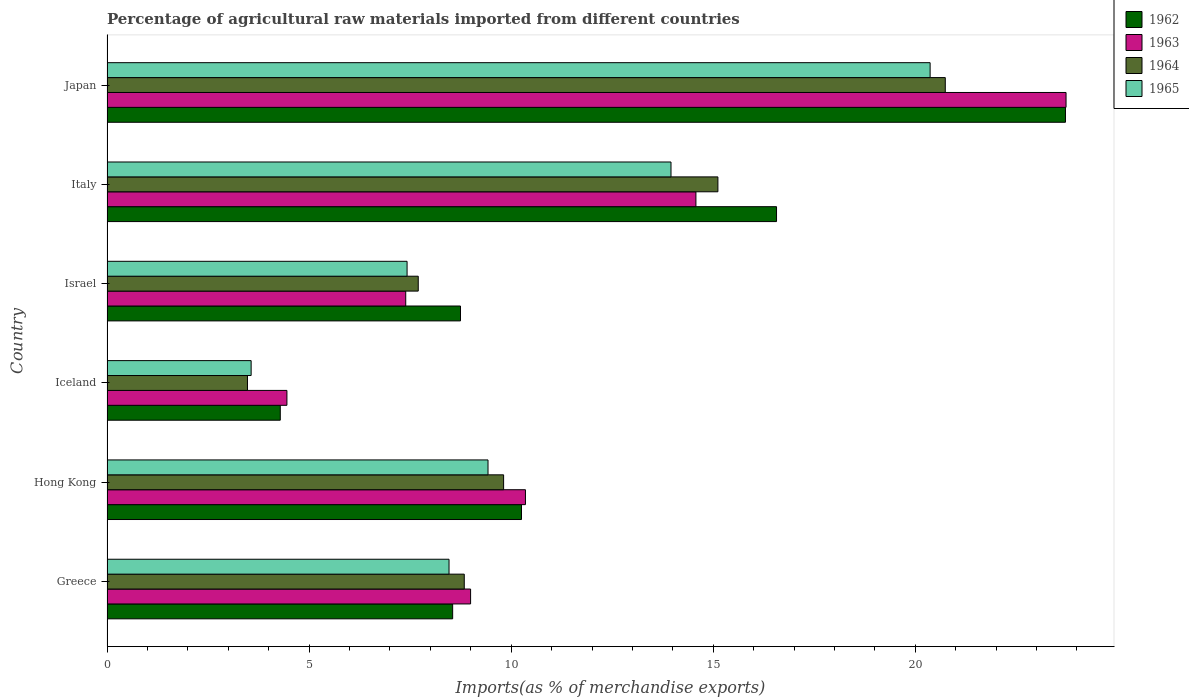Are the number of bars on each tick of the Y-axis equal?
Make the answer very short. Yes. How many bars are there on the 3rd tick from the bottom?
Your response must be concise. 4. What is the label of the 2nd group of bars from the top?
Ensure brevity in your answer.  Italy. In how many cases, is the number of bars for a given country not equal to the number of legend labels?
Offer a very short reply. 0. What is the percentage of imports to different countries in 1962 in Italy?
Make the answer very short. 16.57. Across all countries, what is the maximum percentage of imports to different countries in 1962?
Provide a succinct answer. 23.71. Across all countries, what is the minimum percentage of imports to different countries in 1965?
Ensure brevity in your answer.  3.57. In which country was the percentage of imports to different countries in 1963 maximum?
Offer a terse response. Japan. In which country was the percentage of imports to different countries in 1962 minimum?
Give a very brief answer. Iceland. What is the total percentage of imports to different countries in 1965 in the graph?
Provide a short and direct response. 63.2. What is the difference between the percentage of imports to different countries in 1963 in Greece and that in Iceland?
Ensure brevity in your answer.  4.54. What is the difference between the percentage of imports to different countries in 1962 in Japan and the percentage of imports to different countries in 1963 in Israel?
Give a very brief answer. 16.32. What is the average percentage of imports to different countries in 1963 per country?
Your response must be concise. 11.58. What is the difference between the percentage of imports to different countries in 1965 and percentage of imports to different countries in 1963 in Hong Kong?
Make the answer very short. -0.93. In how many countries, is the percentage of imports to different countries in 1964 greater than 19 %?
Make the answer very short. 1. What is the ratio of the percentage of imports to different countries in 1965 in Hong Kong to that in Italy?
Provide a short and direct response. 0.68. What is the difference between the highest and the second highest percentage of imports to different countries in 1963?
Your answer should be very brief. 9.16. What is the difference between the highest and the lowest percentage of imports to different countries in 1965?
Make the answer very short. 16.8. In how many countries, is the percentage of imports to different countries in 1963 greater than the average percentage of imports to different countries in 1963 taken over all countries?
Provide a short and direct response. 2. What does the 2nd bar from the top in Iceland represents?
Your response must be concise. 1964. What does the 3rd bar from the bottom in Greece represents?
Offer a very short reply. 1964. How many bars are there?
Provide a succinct answer. 24. Does the graph contain any zero values?
Your answer should be very brief. No. Does the graph contain grids?
Your answer should be compact. No. What is the title of the graph?
Make the answer very short. Percentage of agricultural raw materials imported from different countries. What is the label or title of the X-axis?
Provide a succinct answer. Imports(as % of merchandise exports). What is the label or title of the Y-axis?
Your answer should be very brief. Country. What is the Imports(as % of merchandise exports) in 1962 in Greece?
Your answer should be very brief. 8.55. What is the Imports(as % of merchandise exports) of 1963 in Greece?
Your response must be concise. 9. What is the Imports(as % of merchandise exports) of 1964 in Greece?
Keep it short and to the point. 8.84. What is the Imports(as % of merchandise exports) of 1965 in Greece?
Ensure brevity in your answer.  8.46. What is the Imports(as % of merchandise exports) of 1962 in Hong Kong?
Provide a succinct answer. 10.26. What is the Imports(as % of merchandise exports) in 1963 in Hong Kong?
Keep it short and to the point. 10.35. What is the Imports(as % of merchandise exports) of 1964 in Hong Kong?
Your answer should be very brief. 9.81. What is the Imports(as % of merchandise exports) in 1965 in Hong Kong?
Keep it short and to the point. 9.43. What is the Imports(as % of merchandise exports) of 1962 in Iceland?
Keep it short and to the point. 4.29. What is the Imports(as % of merchandise exports) in 1963 in Iceland?
Provide a short and direct response. 4.45. What is the Imports(as % of merchandise exports) of 1964 in Iceland?
Give a very brief answer. 3.48. What is the Imports(as % of merchandise exports) of 1965 in Iceland?
Offer a very short reply. 3.57. What is the Imports(as % of merchandise exports) in 1962 in Israel?
Give a very brief answer. 8.75. What is the Imports(as % of merchandise exports) in 1963 in Israel?
Provide a succinct answer. 7.39. What is the Imports(as % of merchandise exports) of 1964 in Israel?
Offer a terse response. 7.7. What is the Imports(as % of merchandise exports) in 1965 in Israel?
Ensure brevity in your answer.  7.42. What is the Imports(as % of merchandise exports) in 1962 in Italy?
Your answer should be compact. 16.57. What is the Imports(as % of merchandise exports) in 1963 in Italy?
Your answer should be very brief. 14.57. What is the Imports(as % of merchandise exports) in 1964 in Italy?
Provide a succinct answer. 15.12. What is the Imports(as % of merchandise exports) of 1965 in Italy?
Your answer should be very brief. 13.95. What is the Imports(as % of merchandise exports) of 1962 in Japan?
Your answer should be compact. 23.71. What is the Imports(as % of merchandise exports) of 1963 in Japan?
Make the answer very short. 23.73. What is the Imports(as % of merchandise exports) in 1964 in Japan?
Ensure brevity in your answer.  20.74. What is the Imports(as % of merchandise exports) in 1965 in Japan?
Provide a succinct answer. 20.37. Across all countries, what is the maximum Imports(as % of merchandise exports) of 1962?
Offer a very short reply. 23.71. Across all countries, what is the maximum Imports(as % of merchandise exports) in 1963?
Keep it short and to the point. 23.73. Across all countries, what is the maximum Imports(as % of merchandise exports) of 1964?
Your answer should be compact. 20.74. Across all countries, what is the maximum Imports(as % of merchandise exports) of 1965?
Ensure brevity in your answer.  20.37. Across all countries, what is the minimum Imports(as % of merchandise exports) of 1962?
Offer a very short reply. 4.29. Across all countries, what is the minimum Imports(as % of merchandise exports) of 1963?
Offer a terse response. 4.45. Across all countries, what is the minimum Imports(as % of merchandise exports) in 1964?
Ensure brevity in your answer.  3.48. Across all countries, what is the minimum Imports(as % of merchandise exports) of 1965?
Ensure brevity in your answer.  3.57. What is the total Imports(as % of merchandise exports) of 1962 in the graph?
Offer a very short reply. 72.12. What is the total Imports(as % of merchandise exports) in 1963 in the graph?
Your response must be concise. 69.49. What is the total Imports(as % of merchandise exports) of 1964 in the graph?
Your response must be concise. 65.69. What is the total Imports(as % of merchandise exports) in 1965 in the graph?
Provide a short and direct response. 63.2. What is the difference between the Imports(as % of merchandise exports) in 1962 in Greece and that in Hong Kong?
Your response must be concise. -1.7. What is the difference between the Imports(as % of merchandise exports) in 1963 in Greece and that in Hong Kong?
Your answer should be very brief. -1.36. What is the difference between the Imports(as % of merchandise exports) in 1964 in Greece and that in Hong Kong?
Your answer should be compact. -0.97. What is the difference between the Imports(as % of merchandise exports) of 1965 in Greece and that in Hong Kong?
Provide a short and direct response. -0.96. What is the difference between the Imports(as % of merchandise exports) of 1962 in Greece and that in Iceland?
Your response must be concise. 4.26. What is the difference between the Imports(as % of merchandise exports) of 1963 in Greece and that in Iceland?
Offer a very short reply. 4.54. What is the difference between the Imports(as % of merchandise exports) in 1964 in Greece and that in Iceland?
Provide a short and direct response. 5.36. What is the difference between the Imports(as % of merchandise exports) in 1965 in Greece and that in Iceland?
Your answer should be very brief. 4.9. What is the difference between the Imports(as % of merchandise exports) of 1962 in Greece and that in Israel?
Keep it short and to the point. -0.19. What is the difference between the Imports(as % of merchandise exports) in 1963 in Greece and that in Israel?
Your answer should be compact. 1.6. What is the difference between the Imports(as % of merchandise exports) in 1964 in Greece and that in Israel?
Provide a short and direct response. 1.14. What is the difference between the Imports(as % of merchandise exports) of 1965 in Greece and that in Israel?
Offer a very short reply. 1.04. What is the difference between the Imports(as % of merchandise exports) of 1962 in Greece and that in Italy?
Your answer should be very brief. -8.01. What is the difference between the Imports(as % of merchandise exports) in 1963 in Greece and that in Italy?
Offer a very short reply. -5.58. What is the difference between the Imports(as % of merchandise exports) in 1964 in Greece and that in Italy?
Keep it short and to the point. -6.28. What is the difference between the Imports(as % of merchandise exports) of 1965 in Greece and that in Italy?
Keep it short and to the point. -5.49. What is the difference between the Imports(as % of merchandise exports) of 1962 in Greece and that in Japan?
Provide a succinct answer. -15.16. What is the difference between the Imports(as % of merchandise exports) of 1963 in Greece and that in Japan?
Provide a succinct answer. -14.73. What is the difference between the Imports(as % of merchandise exports) in 1964 in Greece and that in Japan?
Your answer should be very brief. -11.9. What is the difference between the Imports(as % of merchandise exports) of 1965 in Greece and that in Japan?
Your response must be concise. -11.9. What is the difference between the Imports(as % of merchandise exports) of 1962 in Hong Kong and that in Iceland?
Make the answer very short. 5.97. What is the difference between the Imports(as % of merchandise exports) in 1963 in Hong Kong and that in Iceland?
Your response must be concise. 5.9. What is the difference between the Imports(as % of merchandise exports) of 1964 in Hong Kong and that in Iceland?
Provide a succinct answer. 6.34. What is the difference between the Imports(as % of merchandise exports) in 1965 in Hong Kong and that in Iceland?
Provide a succinct answer. 5.86. What is the difference between the Imports(as % of merchandise exports) in 1962 in Hong Kong and that in Israel?
Provide a short and direct response. 1.51. What is the difference between the Imports(as % of merchandise exports) in 1963 in Hong Kong and that in Israel?
Ensure brevity in your answer.  2.96. What is the difference between the Imports(as % of merchandise exports) in 1964 in Hong Kong and that in Israel?
Offer a very short reply. 2.11. What is the difference between the Imports(as % of merchandise exports) of 1965 in Hong Kong and that in Israel?
Offer a very short reply. 2. What is the difference between the Imports(as % of merchandise exports) in 1962 in Hong Kong and that in Italy?
Provide a short and direct response. -6.31. What is the difference between the Imports(as % of merchandise exports) of 1963 in Hong Kong and that in Italy?
Offer a terse response. -4.22. What is the difference between the Imports(as % of merchandise exports) of 1964 in Hong Kong and that in Italy?
Give a very brief answer. -5.3. What is the difference between the Imports(as % of merchandise exports) in 1965 in Hong Kong and that in Italy?
Make the answer very short. -4.53. What is the difference between the Imports(as % of merchandise exports) of 1962 in Hong Kong and that in Japan?
Provide a succinct answer. -13.46. What is the difference between the Imports(as % of merchandise exports) of 1963 in Hong Kong and that in Japan?
Ensure brevity in your answer.  -13.38. What is the difference between the Imports(as % of merchandise exports) of 1964 in Hong Kong and that in Japan?
Your response must be concise. -10.93. What is the difference between the Imports(as % of merchandise exports) in 1965 in Hong Kong and that in Japan?
Keep it short and to the point. -10.94. What is the difference between the Imports(as % of merchandise exports) in 1962 in Iceland and that in Israel?
Provide a succinct answer. -4.46. What is the difference between the Imports(as % of merchandise exports) in 1963 in Iceland and that in Israel?
Give a very brief answer. -2.94. What is the difference between the Imports(as % of merchandise exports) of 1964 in Iceland and that in Israel?
Ensure brevity in your answer.  -4.23. What is the difference between the Imports(as % of merchandise exports) of 1965 in Iceland and that in Israel?
Ensure brevity in your answer.  -3.86. What is the difference between the Imports(as % of merchandise exports) of 1962 in Iceland and that in Italy?
Your response must be concise. -12.28. What is the difference between the Imports(as % of merchandise exports) of 1963 in Iceland and that in Italy?
Give a very brief answer. -10.12. What is the difference between the Imports(as % of merchandise exports) of 1964 in Iceland and that in Italy?
Offer a very short reply. -11.64. What is the difference between the Imports(as % of merchandise exports) of 1965 in Iceland and that in Italy?
Provide a succinct answer. -10.39. What is the difference between the Imports(as % of merchandise exports) in 1962 in Iceland and that in Japan?
Provide a succinct answer. -19.43. What is the difference between the Imports(as % of merchandise exports) in 1963 in Iceland and that in Japan?
Offer a very short reply. -19.28. What is the difference between the Imports(as % of merchandise exports) in 1964 in Iceland and that in Japan?
Make the answer very short. -17.27. What is the difference between the Imports(as % of merchandise exports) in 1965 in Iceland and that in Japan?
Ensure brevity in your answer.  -16.8. What is the difference between the Imports(as % of merchandise exports) in 1962 in Israel and that in Italy?
Your answer should be compact. -7.82. What is the difference between the Imports(as % of merchandise exports) of 1963 in Israel and that in Italy?
Your response must be concise. -7.18. What is the difference between the Imports(as % of merchandise exports) in 1964 in Israel and that in Italy?
Offer a very short reply. -7.41. What is the difference between the Imports(as % of merchandise exports) in 1965 in Israel and that in Italy?
Make the answer very short. -6.53. What is the difference between the Imports(as % of merchandise exports) of 1962 in Israel and that in Japan?
Your answer should be very brief. -14.97. What is the difference between the Imports(as % of merchandise exports) in 1963 in Israel and that in Japan?
Your answer should be very brief. -16.34. What is the difference between the Imports(as % of merchandise exports) of 1964 in Israel and that in Japan?
Give a very brief answer. -13.04. What is the difference between the Imports(as % of merchandise exports) in 1965 in Israel and that in Japan?
Make the answer very short. -12.94. What is the difference between the Imports(as % of merchandise exports) in 1962 in Italy and that in Japan?
Make the answer very short. -7.15. What is the difference between the Imports(as % of merchandise exports) in 1963 in Italy and that in Japan?
Keep it short and to the point. -9.16. What is the difference between the Imports(as % of merchandise exports) in 1964 in Italy and that in Japan?
Give a very brief answer. -5.63. What is the difference between the Imports(as % of merchandise exports) in 1965 in Italy and that in Japan?
Give a very brief answer. -6.41. What is the difference between the Imports(as % of merchandise exports) of 1962 in Greece and the Imports(as % of merchandise exports) of 1963 in Hong Kong?
Your answer should be very brief. -1.8. What is the difference between the Imports(as % of merchandise exports) in 1962 in Greece and the Imports(as % of merchandise exports) in 1964 in Hong Kong?
Offer a terse response. -1.26. What is the difference between the Imports(as % of merchandise exports) in 1962 in Greece and the Imports(as % of merchandise exports) in 1965 in Hong Kong?
Your answer should be very brief. -0.88. What is the difference between the Imports(as % of merchandise exports) in 1963 in Greece and the Imports(as % of merchandise exports) in 1964 in Hong Kong?
Provide a short and direct response. -0.82. What is the difference between the Imports(as % of merchandise exports) of 1963 in Greece and the Imports(as % of merchandise exports) of 1965 in Hong Kong?
Your answer should be compact. -0.43. What is the difference between the Imports(as % of merchandise exports) of 1964 in Greece and the Imports(as % of merchandise exports) of 1965 in Hong Kong?
Provide a short and direct response. -0.59. What is the difference between the Imports(as % of merchandise exports) of 1962 in Greece and the Imports(as % of merchandise exports) of 1963 in Iceland?
Offer a terse response. 4.1. What is the difference between the Imports(as % of merchandise exports) of 1962 in Greece and the Imports(as % of merchandise exports) of 1964 in Iceland?
Your answer should be very brief. 5.08. What is the difference between the Imports(as % of merchandise exports) in 1962 in Greece and the Imports(as % of merchandise exports) in 1965 in Iceland?
Your answer should be very brief. 4.99. What is the difference between the Imports(as % of merchandise exports) of 1963 in Greece and the Imports(as % of merchandise exports) of 1964 in Iceland?
Your response must be concise. 5.52. What is the difference between the Imports(as % of merchandise exports) in 1963 in Greece and the Imports(as % of merchandise exports) in 1965 in Iceland?
Offer a terse response. 5.43. What is the difference between the Imports(as % of merchandise exports) in 1964 in Greece and the Imports(as % of merchandise exports) in 1965 in Iceland?
Keep it short and to the point. 5.27. What is the difference between the Imports(as % of merchandise exports) of 1962 in Greece and the Imports(as % of merchandise exports) of 1963 in Israel?
Offer a very short reply. 1.16. What is the difference between the Imports(as % of merchandise exports) of 1962 in Greece and the Imports(as % of merchandise exports) of 1964 in Israel?
Your response must be concise. 0.85. What is the difference between the Imports(as % of merchandise exports) in 1962 in Greece and the Imports(as % of merchandise exports) in 1965 in Israel?
Keep it short and to the point. 1.13. What is the difference between the Imports(as % of merchandise exports) in 1963 in Greece and the Imports(as % of merchandise exports) in 1964 in Israel?
Make the answer very short. 1.3. What is the difference between the Imports(as % of merchandise exports) of 1963 in Greece and the Imports(as % of merchandise exports) of 1965 in Israel?
Provide a short and direct response. 1.57. What is the difference between the Imports(as % of merchandise exports) of 1964 in Greece and the Imports(as % of merchandise exports) of 1965 in Israel?
Provide a succinct answer. 1.42. What is the difference between the Imports(as % of merchandise exports) in 1962 in Greece and the Imports(as % of merchandise exports) in 1963 in Italy?
Offer a very short reply. -6.02. What is the difference between the Imports(as % of merchandise exports) of 1962 in Greece and the Imports(as % of merchandise exports) of 1964 in Italy?
Your answer should be compact. -6.56. What is the difference between the Imports(as % of merchandise exports) in 1962 in Greece and the Imports(as % of merchandise exports) in 1965 in Italy?
Your answer should be very brief. -5.4. What is the difference between the Imports(as % of merchandise exports) of 1963 in Greece and the Imports(as % of merchandise exports) of 1964 in Italy?
Give a very brief answer. -6.12. What is the difference between the Imports(as % of merchandise exports) in 1963 in Greece and the Imports(as % of merchandise exports) in 1965 in Italy?
Offer a very short reply. -4.96. What is the difference between the Imports(as % of merchandise exports) in 1964 in Greece and the Imports(as % of merchandise exports) in 1965 in Italy?
Provide a short and direct response. -5.12. What is the difference between the Imports(as % of merchandise exports) in 1962 in Greece and the Imports(as % of merchandise exports) in 1963 in Japan?
Ensure brevity in your answer.  -15.18. What is the difference between the Imports(as % of merchandise exports) in 1962 in Greece and the Imports(as % of merchandise exports) in 1964 in Japan?
Offer a very short reply. -12.19. What is the difference between the Imports(as % of merchandise exports) in 1962 in Greece and the Imports(as % of merchandise exports) in 1965 in Japan?
Provide a succinct answer. -11.81. What is the difference between the Imports(as % of merchandise exports) in 1963 in Greece and the Imports(as % of merchandise exports) in 1964 in Japan?
Your answer should be compact. -11.75. What is the difference between the Imports(as % of merchandise exports) of 1963 in Greece and the Imports(as % of merchandise exports) of 1965 in Japan?
Your answer should be compact. -11.37. What is the difference between the Imports(as % of merchandise exports) in 1964 in Greece and the Imports(as % of merchandise exports) in 1965 in Japan?
Your answer should be compact. -11.53. What is the difference between the Imports(as % of merchandise exports) of 1962 in Hong Kong and the Imports(as % of merchandise exports) of 1963 in Iceland?
Provide a short and direct response. 5.8. What is the difference between the Imports(as % of merchandise exports) in 1962 in Hong Kong and the Imports(as % of merchandise exports) in 1964 in Iceland?
Offer a very short reply. 6.78. What is the difference between the Imports(as % of merchandise exports) of 1962 in Hong Kong and the Imports(as % of merchandise exports) of 1965 in Iceland?
Offer a very short reply. 6.69. What is the difference between the Imports(as % of merchandise exports) in 1963 in Hong Kong and the Imports(as % of merchandise exports) in 1964 in Iceland?
Your response must be concise. 6.88. What is the difference between the Imports(as % of merchandise exports) in 1963 in Hong Kong and the Imports(as % of merchandise exports) in 1965 in Iceland?
Your response must be concise. 6.79. What is the difference between the Imports(as % of merchandise exports) in 1964 in Hong Kong and the Imports(as % of merchandise exports) in 1965 in Iceland?
Provide a succinct answer. 6.25. What is the difference between the Imports(as % of merchandise exports) of 1962 in Hong Kong and the Imports(as % of merchandise exports) of 1963 in Israel?
Make the answer very short. 2.86. What is the difference between the Imports(as % of merchandise exports) in 1962 in Hong Kong and the Imports(as % of merchandise exports) in 1964 in Israel?
Provide a succinct answer. 2.55. What is the difference between the Imports(as % of merchandise exports) of 1962 in Hong Kong and the Imports(as % of merchandise exports) of 1965 in Israel?
Give a very brief answer. 2.83. What is the difference between the Imports(as % of merchandise exports) of 1963 in Hong Kong and the Imports(as % of merchandise exports) of 1964 in Israel?
Provide a succinct answer. 2.65. What is the difference between the Imports(as % of merchandise exports) in 1963 in Hong Kong and the Imports(as % of merchandise exports) in 1965 in Israel?
Provide a short and direct response. 2.93. What is the difference between the Imports(as % of merchandise exports) in 1964 in Hong Kong and the Imports(as % of merchandise exports) in 1965 in Israel?
Keep it short and to the point. 2.39. What is the difference between the Imports(as % of merchandise exports) in 1962 in Hong Kong and the Imports(as % of merchandise exports) in 1963 in Italy?
Keep it short and to the point. -4.32. What is the difference between the Imports(as % of merchandise exports) of 1962 in Hong Kong and the Imports(as % of merchandise exports) of 1964 in Italy?
Provide a succinct answer. -4.86. What is the difference between the Imports(as % of merchandise exports) in 1962 in Hong Kong and the Imports(as % of merchandise exports) in 1965 in Italy?
Your answer should be compact. -3.7. What is the difference between the Imports(as % of merchandise exports) in 1963 in Hong Kong and the Imports(as % of merchandise exports) in 1964 in Italy?
Make the answer very short. -4.76. What is the difference between the Imports(as % of merchandise exports) in 1963 in Hong Kong and the Imports(as % of merchandise exports) in 1965 in Italy?
Offer a terse response. -3.6. What is the difference between the Imports(as % of merchandise exports) of 1964 in Hong Kong and the Imports(as % of merchandise exports) of 1965 in Italy?
Your answer should be very brief. -4.14. What is the difference between the Imports(as % of merchandise exports) of 1962 in Hong Kong and the Imports(as % of merchandise exports) of 1963 in Japan?
Ensure brevity in your answer.  -13.47. What is the difference between the Imports(as % of merchandise exports) in 1962 in Hong Kong and the Imports(as % of merchandise exports) in 1964 in Japan?
Give a very brief answer. -10.49. What is the difference between the Imports(as % of merchandise exports) in 1962 in Hong Kong and the Imports(as % of merchandise exports) in 1965 in Japan?
Ensure brevity in your answer.  -10.11. What is the difference between the Imports(as % of merchandise exports) of 1963 in Hong Kong and the Imports(as % of merchandise exports) of 1964 in Japan?
Your response must be concise. -10.39. What is the difference between the Imports(as % of merchandise exports) in 1963 in Hong Kong and the Imports(as % of merchandise exports) in 1965 in Japan?
Offer a very short reply. -10.01. What is the difference between the Imports(as % of merchandise exports) of 1964 in Hong Kong and the Imports(as % of merchandise exports) of 1965 in Japan?
Your answer should be compact. -10.55. What is the difference between the Imports(as % of merchandise exports) in 1962 in Iceland and the Imports(as % of merchandise exports) in 1963 in Israel?
Provide a succinct answer. -3.1. What is the difference between the Imports(as % of merchandise exports) in 1962 in Iceland and the Imports(as % of merchandise exports) in 1964 in Israel?
Ensure brevity in your answer.  -3.41. What is the difference between the Imports(as % of merchandise exports) of 1962 in Iceland and the Imports(as % of merchandise exports) of 1965 in Israel?
Offer a terse response. -3.14. What is the difference between the Imports(as % of merchandise exports) of 1963 in Iceland and the Imports(as % of merchandise exports) of 1964 in Israel?
Your response must be concise. -3.25. What is the difference between the Imports(as % of merchandise exports) in 1963 in Iceland and the Imports(as % of merchandise exports) in 1965 in Israel?
Provide a succinct answer. -2.97. What is the difference between the Imports(as % of merchandise exports) in 1964 in Iceland and the Imports(as % of merchandise exports) in 1965 in Israel?
Ensure brevity in your answer.  -3.95. What is the difference between the Imports(as % of merchandise exports) in 1962 in Iceland and the Imports(as % of merchandise exports) in 1963 in Italy?
Provide a short and direct response. -10.28. What is the difference between the Imports(as % of merchandise exports) in 1962 in Iceland and the Imports(as % of merchandise exports) in 1964 in Italy?
Make the answer very short. -10.83. What is the difference between the Imports(as % of merchandise exports) of 1962 in Iceland and the Imports(as % of merchandise exports) of 1965 in Italy?
Keep it short and to the point. -9.67. What is the difference between the Imports(as % of merchandise exports) in 1963 in Iceland and the Imports(as % of merchandise exports) in 1964 in Italy?
Your answer should be very brief. -10.66. What is the difference between the Imports(as % of merchandise exports) in 1963 in Iceland and the Imports(as % of merchandise exports) in 1965 in Italy?
Your answer should be very brief. -9.5. What is the difference between the Imports(as % of merchandise exports) in 1964 in Iceland and the Imports(as % of merchandise exports) in 1965 in Italy?
Provide a succinct answer. -10.48. What is the difference between the Imports(as % of merchandise exports) in 1962 in Iceland and the Imports(as % of merchandise exports) in 1963 in Japan?
Provide a short and direct response. -19.44. What is the difference between the Imports(as % of merchandise exports) in 1962 in Iceland and the Imports(as % of merchandise exports) in 1964 in Japan?
Your response must be concise. -16.45. What is the difference between the Imports(as % of merchandise exports) in 1962 in Iceland and the Imports(as % of merchandise exports) in 1965 in Japan?
Make the answer very short. -16.08. What is the difference between the Imports(as % of merchandise exports) of 1963 in Iceland and the Imports(as % of merchandise exports) of 1964 in Japan?
Keep it short and to the point. -16.29. What is the difference between the Imports(as % of merchandise exports) of 1963 in Iceland and the Imports(as % of merchandise exports) of 1965 in Japan?
Offer a very short reply. -15.91. What is the difference between the Imports(as % of merchandise exports) of 1964 in Iceland and the Imports(as % of merchandise exports) of 1965 in Japan?
Provide a short and direct response. -16.89. What is the difference between the Imports(as % of merchandise exports) of 1962 in Israel and the Imports(as % of merchandise exports) of 1963 in Italy?
Offer a very short reply. -5.83. What is the difference between the Imports(as % of merchandise exports) of 1962 in Israel and the Imports(as % of merchandise exports) of 1964 in Italy?
Your response must be concise. -6.37. What is the difference between the Imports(as % of merchandise exports) of 1962 in Israel and the Imports(as % of merchandise exports) of 1965 in Italy?
Your answer should be compact. -5.21. What is the difference between the Imports(as % of merchandise exports) of 1963 in Israel and the Imports(as % of merchandise exports) of 1964 in Italy?
Make the answer very short. -7.72. What is the difference between the Imports(as % of merchandise exports) of 1963 in Israel and the Imports(as % of merchandise exports) of 1965 in Italy?
Make the answer very short. -6.56. What is the difference between the Imports(as % of merchandise exports) in 1964 in Israel and the Imports(as % of merchandise exports) in 1965 in Italy?
Your answer should be very brief. -6.25. What is the difference between the Imports(as % of merchandise exports) of 1962 in Israel and the Imports(as % of merchandise exports) of 1963 in Japan?
Give a very brief answer. -14.98. What is the difference between the Imports(as % of merchandise exports) of 1962 in Israel and the Imports(as % of merchandise exports) of 1964 in Japan?
Provide a succinct answer. -11.99. What is the difference between the Imports(as % of merchandise exports) in 1962 in Israel and the Imports(as % of merchandise exports) in 1965 in Japan?
Offer a very short reply. -11.62. What is the difference between the Imports(as % of merchandise exports) of 1963 in Israel and the Imports(as % of merchandise exports) of 1964 in Japan?
Your response must be concise. -13.35. What is the difference between the Imports(as % of merchandise exports) in 1963 in Israel and the Imports(as % of merchandise exports) in 1965 in Japan?
Offer a terse response. -12.97. What is the difference between the Imports(as % of merchandise exports) in 1964 in Israel and the Imports(as % of merchandise exports) in 1965 in Japan?
Your response must be concise. -12.67. What is the difference between the Imports(as % of merchandise exports) of 1962 in Italy and the Imports(as % of merchandise exports) of 1963 in Japan?
Your response must be concise. -7.16. What is the difference between the Imports(as % of merchandise exports) of 1962 in Italy and the Imports(as % of merchandise exports) of 1964 in Japan?
Your response must be concise. -4.18. What is the difference between the Imports(as % of merchandise exports) in 1962 in Italy and the Imports(as % of merchandise exports) in 1965 in Japan?
Your response must be concise. -3.8. What is the difference between the Imports(as % of merchandise exports) in 1963 in Italy and the Imports(as % of merchandise exports) in 1964 in Japan?
Ensure brevity in your answer.  -6.17. What is the difference between the Imports(as % of merchandise exports) in 1963 in Italy and the Imports(as % of merchandise exports) in 1965 in Japan?
Ensure brevity in your answer.  -5.79. What is the difference between the Imports(as % of merchandise exports) in 1964 in Italy and the Imports(as % of merchandise exports) in 1965 in Japan?
Keep it short and to the point. -5.25. What is the average Imports(as % of merchandise exports) of 1962 per country?
Provide a succinct answer. 12.02. What is the average Imports(as % of merchandise exports) of 1963 per country?
Give a very brief answer. 11.58. What is the average Imports(as % of merchandise exports) in 1964 per country?
Provide a short and direct response. 10.95. What is the average Imports(as % of merchandise exports) of 1965 per country?
Ensure brevity in your answer.  10.53. What is the difference between the Imports(as % of merchandise exports) of 1962 and Imports(as % of merchandise exports) of 1963 in Greece?
Ensure brevity in your answer.  -0.44. What is the difference between the Imports(as % of merchandise exports) of 1962 and Imports(as % of merchandise exports) of 1964 in Greece?
Keep it short and to the point. -0.29. What is the difference between the Imports(as % of merchandise exports) of 1962 and Imports(as % of merchandise exports) of 1965 in Greece?
Provide a succinct answer. 0.09. What is the difference between the Imports(as % of merchandise exports) of 1963 and Imports(as % of merchandise exports) of 1964 in Greece?
Give a very brief answer. 0.16. What is the difference between the Imports(as % of merchandise exports) of 1963 and Imports(as % of merchandise exports) of 1965 in Greece?
Give a very brief answer. 0.53. What is the difference between the Imports(as % of merchandise exports) in 1964 and Imports(as % of merchandise exports) in 1965 in Greece?
Your answer should be compact. 0.38. What is the difference between the Imports(as % of merchandise exports) in 1962 and Imports(as % of merchandise exports) in 1963 in Hong Kong?
Give a very brief answer. -0.1. What is the difference between the Imports(as % of merchandise exports) in 1962 and Imports(as % of merchandise exports) in 1964 in Hong Kong?
Your answer should be compact. 0.44. What is the difference between the Imports(as % of merchandise exports) in 1962 and Imports(as % of merchandise exports) in 1965 in Hong Kong?
Give a very brief answer. 0.83. What is the difference between the Imports(as % of merchandise exports) in 1963 and Imports(as % of merchandise exports) in 1964 in Hong Kong?
Your answer should be very brief. 0.54. What is the difference between the Imports(as % of merchandise exports) in 1963 and Imports(as % of merchandise exports) in 1965 in Hong Kong?
Provide a short and direct response. 0.93. What is the difference between the Imports(as % of merchandise exports) in 1964 and Imports(as % of merchandise exports) in 1965 in Hong Kong?
Provide a short and direct response. 0.39. What is the difference between the Imports(as % of merchandise exports) of 1962 and Imports(as % of merchandise exports) of 1963 in Iceland?
Give a very brief answer. -0.16. What is the difference between the Imports(as % of merchandise exports) in 1962 and Imports(as % of merchandise exports) in 1964 in Iceland?
Make the answer very short. 0.81. What is the difference between the Imports(as % of merchandise exports) of 1962 and Imports(as % of merchandise exports) of 1965 in Iceland?
Make the answer very short. 0.72. What is the difference between the Imports(as % of merchandise exports) of 1963 and Imports(as % of merchandise exports) of 1964 in Iceland?
Give a very brief answer. 0.98. What is the difference between the Imports(as % of merchandise exports) of 1963 and Imports(as % of merchandise exports) of 1965 in Iceland?
Your answer should be very brief. 0.89. What is the difference between the Imports(as % of merchandise exports) of 1964 and Imports(as % of merchandise exports) of 1965 in Iceland?
Offer a terse response. -0.09. What is the difference between the Imports(as % of merchandise exports) of 1962 and Imports(as % of merchandise exports) of 1963 in Israel?
Provide a short and direct response. 1.36. What is the difference between the Imports(as % of merchandise exports) in 1962 and Imports(as % of merchandise exports) in 1964 in Israel?
Provide a short and direct response. 1.05. What is the difference between the Imports(as % of merchandise exports) of 1962 and Imports(as % of merchandise exports) of 1965 in Israel?
Provide a succinct answer. 1.32. What is the difference between the Imports(as % of merchandise exports) in 1963 and Imports(as % of merchandise exports) in 1964 in Israel?
Provide a short and direct response. -0.31. What is the difference between the Imports(as % of merchandise exports) of 1963 and Imports(as % of merchandise exports) of 1965 in Israel?
Offer a very short reply. -0.03. What is the difference between the Imports(as % of merchandise exports) of 1964 and Imports(as % of merchandise exports) of 1965 in Israel?
Provide a succinct answer. 0.28. What is the difference between the Imports(as % of merchandise exports) of 1962 and Imports(as % of merchandise exports) of 1963 in Italy?
Your answer should be compact. 1.99. What is the difference between the Imports(as % of merchandise exports) in 1962 and Imports(as % of merchandise exports) in 1964 in Italy?
Provide a succinct answer. 1.45. What is the difference between the Imports(as % of merchandise exports) of 1962 and Imports(as % of merchandise exports) of 1965 in Italy?
Provide a short and direct response. 2.61. What is the difference between the Imports(as % of merchandise exports) of 1963 and Imports(as % of merchandise exports) of 1964 in Italy?
Provide a succinct answer. -0.54. What is the difference between the Imports(as % of merchandise exports) in 1963 and Imports(as % of merchandise exports) in 1965 in Italy?
Give a very brief answer. 0.62. What is the difference between the Imports(as % of merchandise exports) of 1964 and Imports(as % of merchandise exports) of 1965 in Italy?
Offer a very short reply. 1.16. What is the difference between the Imports(as % of merchandise exports) of 1962 and Imports(as % of merchandise exports) of 1963 in Japan?
Your answer should be compact. -0.01. What is the difference between the Imports(as % of merchandise exports) of 1962 and Imports(as % of merchandise exports) of 1964 in Japan?
Offer a terse response. 2.97. What is the difference between the Imports(as % of merchandise exports) of 1962 and Imports(as % of merchandise exports) of 1965 in Japan?
Make the answer very short. 3.35. What is the difference between the Imports(as % of merchandise exports) of 1963 and Imports(as % of merchandise exports) of 1964 in Japan?
Ensure brevity in your answer.  2.99. What is the difference between the Imports(as % of merchandise exports) in 1963 and Imports(as % of merchandise exports) in 1965 in Japan?
Your answer should be very brief. 3.36. What is the difference between the Imports(as % of merchandise exports) of 1964 and Imports(as % of merchandise exports) of 1965 in Japan?
Provide a succinct answer. 0.38. What is the ratio of the Imports(as % of merchandise exports) of 1962 in Greece to that in Hong Kong?
Your answer should be compact. 0.83. What is the ratio of the Imports(as % of merchandise exports) in 1963 in Greece to that in Hong Kong?
Provide a succinct answer. 0.87. What is the ratio of the Imports(as % of merchandise exports) in 1964 in Greece to that in Hong Kong?
Your answer should be compact. 0.9. What is the ratio of the Imports(as % of merchandise exports) of 1965 in Greece to that in Hong Kong?
Ensure brevity in your answer.  0.9. What is the ratio of the Imports(as % of merchandise exports) of 1962 in Greece to that in Iceland?
Give a very brief answer. 1.99. What is the ratio of the Imports(as % of merchandise exports) in 1963 in Greece to that in Iceland?
Offer a terse response. 2.02. What is the ratio of the Imports(as % of merchandise exports) in 1964 in Greece to that in Iceland?
Ensure brevity in your answer.  2.54. What is the ratio of the Imports(as % of merchandise exports) in 1965 in Greece to that in Iceland?
Offer a very short reply. 2.37. What is the ratio of the Imports(as % of merchandise exports) in 1962 in Greece to that in Israel?
Ensure brevity in your answer.  0.98. What is the ratio of the Imports(as % of merchandise exports) in 1963 in Greece to that in Israel?
Give a very brief answer. 1.22. What is the ratio of the Imports(as % of merchandise exports) of 1964 in Greece to that in Israel?
Ensure brevity in your answer.  1.15. What is the ratio of the Imports(as % of merchandise exports) in 1965 in Greece to that in Israel?
Your response must be concise. 1.14. What is the ratio of the Imports(as % of merchandise exports) in 1962 in Greece to that in Italy?
Offer a terse response. 0.52. What is the ratio of the Imports(as % of merchandise exports) of 1963 in Greece to that in Italy?
Offer a very short reply. 0.62. What is the ratio of the Imports(as % of merchandise exports) of 1964 in Greece to that in Italy?
Provide a succinct answer. 0.58. What is the ratio of the Imports(as % of merchandise exports) in 1965 in Greece to that in Italy?
Make the answer very short. 0.61. What is the ratio of the Imports(as % of merchandise exports) of 1962 in Greece to that in Japan?
Make the answer very short. 0.36. What is the ratio of the Imports(as % of merchandise exports) of 1963 in Greece to that in Japan?
Keep it short and to the point. 0.38. What is the ratio of the Imports(as % of merchandise exports) in 1964 in Greece to that in Japan?
Your answer should be compact. 0.43. What is the ratio of the Imports(as % of merchandise exports) in 1965 in Greece to that in Japan?
Your answer should be very brief. 0.42. What is the ratio of the Imports(as % of merchandise exports) in 1962 in Hong Kong to that in Iceland?
Provide a succinct answer. 2.39. What is the ratio of the Imports(as % of merchandise exports) in 1963 in Hong Kong to that in Iceland?
Your answer should be very brief. 2.33. What is the ratio of the Imports(as % of merchandise exports) of 1964 in Hong Kong to that in Iceland?
Ensure brevity in your answer.  2.82. What is the ratio of the Imports(as % of merchandise exports) in 1965 in Hong Kong to that in Iceland?
Offer a very short reply. 2.64. What is the ratio of the Imports(as % of merchandise exports) of 1962 in Hong Kong to that in Israel?
Ensure brevity in your answer.  1.17. What is the ratio of the Imports(as % of merchandise exports) of 1963 in Hong Kong to that in Israel?
Ensure brevity in your answer.  1.4. What is the ratio of the Imports(as % of merchandise exports) in 1964 in Hong Kong to that in Israel?
Provide a succinct answer. 1.27. What is the ratio of the Imports(as % of merchandise exports) in 1965 in Hong Kong to that in Israel?
Your response must be concise. 1.27. What is the ratio of the Imports(as % of merchandise exports) of 1962 in Hong Kong to that in Italy?
Your answer should be very brief. 0.62. What is the ratio of the Imports(as % of merchandise exports) of 1963 in Hong Kong to that in Italy?
Your answer should be very brief. 0.71. What is the ratio of the Imports(as % of merchandise exports) in 1964 in Hong Kong to that in Italy?
Your answer should be very brief. 0.65. What is the ratio of the Imports(as % of merchandise exports) in 1965 in Hong Kong to that in Italy?
Offer a very short reply. 0.68. What is the ratio of the Imports(as % of merchandise exports) in 1962 in Hong Kong to that in Japan?
Offer a very short reply. 0.43. What is the ratio of the Imports(as % of merchandise exports) in 1963 in Hong Kong to that in Japan?
Offer a terse response. 0.44. What is the ratio of the Imports(as % of merchandise exports) of 1964 in Hong Kong to that in Japan?
Offer a very short reply. 0.47. What is the ratio of the Imports(as % of merchandise exports) of 1965 in Hong Kong to that in Japan?
Your answer should be very brief. 0.46. What is the ratio of the Imports(as % of merchandise exports) in 1962 in Iceland to that in Israel?
Your answer should be compact. 0.49. What is the ratio of the Imports(as % of merchandise exports) in 1963 in Iceland to that in Israel?
Your answer should be compact. 0.6. What is the ratio of the Imports(as % of merchandise exports) in 1964 in Iceland to that in Israel?
Ensure brevity in your answer.  0.45. What is the ratio of the Imports(as % of merchandise exports) in 1965 in Iceland to that in Israel?
Ensure brevity in your answer.  0.48. What is the ratio of the Imports(as % of merchandise exports) in 1962 in Iceland to that in Italy?
Offer a very short reply. 0.26. What is the ratio of the Imports(as % of merchandise exports) in 1963 in Iceland to that in Italy?
Make the answer very short. 0.31. What is the ratio of the Imports(as % of merchandise exports) of 1964 in Iceland to that in Italy?
Provide a short and direct response. 0.23. What is the ratio of the Imports(as % of merchandise exports) in 1965 in Iceland to that in Italy?
Your response must be concise. 0.26. What is the ratio of the Imports(as % of merchandise exports) of 1962 in Iceland to that in Japan?
Make the answer very short. 0.18. What is the ratio of the Imports(as % of merchandise exports) of 1963 in Iceland to that in Japan?
Offer a terse response. 0.19. What is the ratio of the Imports(as % of merchandise exports) of 1964 in Iceland to that in Japan?
Give a very brief answer. 0.17. What is the ratio of the Imports(as % of merchandise exports) in 1965 in Iceland to that in Japan?
Make the answer very short. 0.18. What is the ratio of the Imports(as % of merchandise exports) in 1962 in Israel to that in Italy?
Ensure brevity in your answer.  0.53. What is the ratio of the Imports(as % of merchandise exports) of 1963 in Israel to that in Italy?
Make the answer very short. 0.51. What is the ratio of the Imports(as % of merchandise exports) in 1964 in Israel to that in Italy?
Give a very brief answer. 0.51. What is the ratio of the Imports(as % of merchandise exports) of 1965 in Israel to that in Italy?
Provide a succinct answer. 0.53. What is the ratio of the Imports(as % of merchandise exports) in 1962 in Israel to that in Japan?
Provide a short and direct response. 0.37. What is the ratio of the Imports(as % of merchandise exports) of 1963 in Israel to that in Japan?
Keep it short and to the point. 0.31. What is the ratio of the Imports(as % of merchandise exports) in 1964 in Israel to that in Japan?
Make the answer very short. 0.37. What is the ratio of the Imports(as % of merchandise exports) in 1965 in Israel to that in Japan?
Ensure brevity in your answer.  0.36. What is the ratio of the Imports(as % of merchandise exports) in 1962 in Italy to that in Japan?
Your answer should be compact. 0.7. What is the ratio of the Imports(as % of merchandise exports) of 1963 in Italy to that in Japan?
Provide a short and direct response. 0.61. What is the ratio of the Imports(as % of merchandise exports) in 1964 in Italy to that in Japan?
Keep it short and to the point. 0.73. What is the ratio of the Imports(as % of merchandise exports) of 1965 in Italy to that in Japan?
Offer a terse response. 0.69. What is the difference between the highest and the second highest Imports(as % of merchandise exports) in 1962?
Offer a very short reply. 7.15. What is the difference between the highest and the second highest Imports(as % of merchandise exports) in 1963?
Provide a succinct answer. 9.16. What is the difference between the highest and the second highest Imports(as % of merchandise exports) in 1964?
Make the answer very short. 5.63. What is the difference between the highest and the second highest Imports(as % of merchandise exports) of 1965?
Keep it short and to the point. 6.41. What is the difference between the highest and the lowest Imports(as % of merchandise exports) of 1962?
Your answer should be very brief. 19.43. What is the difference between the highest and the lowest Imports(as % of merchandise exports) of 1963?
Provide a short and direct response. 19.28. What is the difference between the highest and the lowest Imports(as % of merchandise exports) of 1964?
Offer a terse response. 17.27. What is the difference between the highest and the lowest Imports(as % of merchandise exports) of 1965?
Provide a succinct answer. 16.8. 